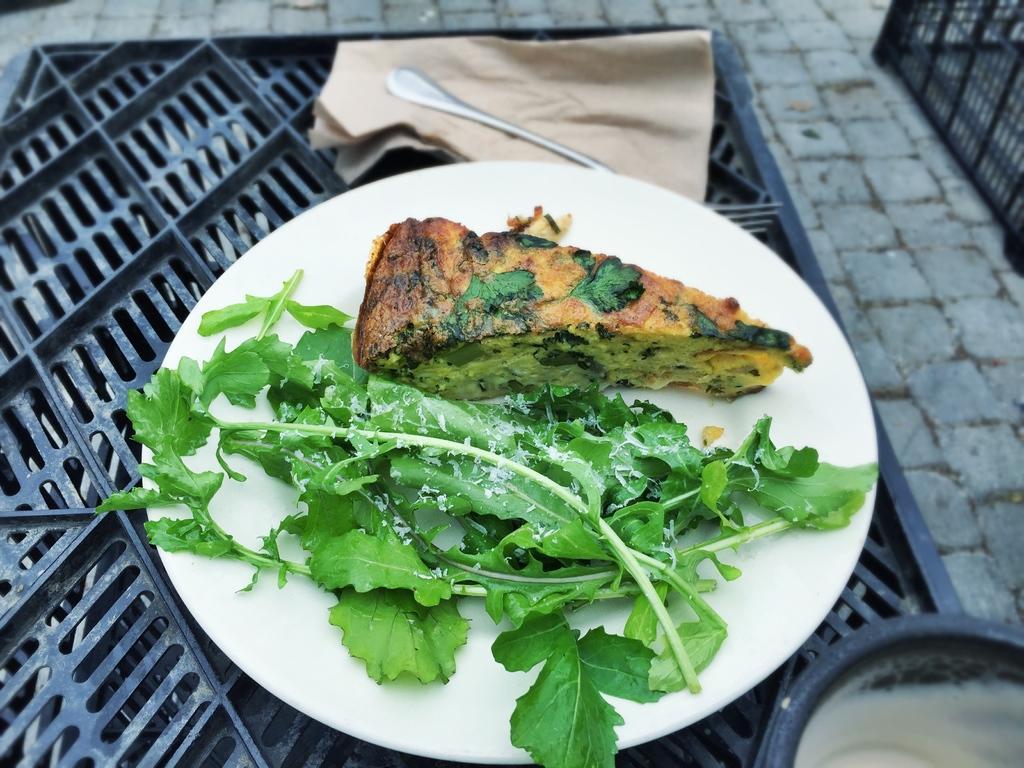How would you summarize this image in a sentence or two? In the center of the image we can see food in plate placed on the grill. 